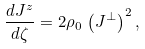Convert formula to latex. <formula><loc_0><loc_0><loc_500><loc_500>\frac { d J ^ { z } } { d \zeta } = 2 \rho _ { 0 } \, \left ( J ^ { \perp } \right ) ^ { 2 } ,</formula> 